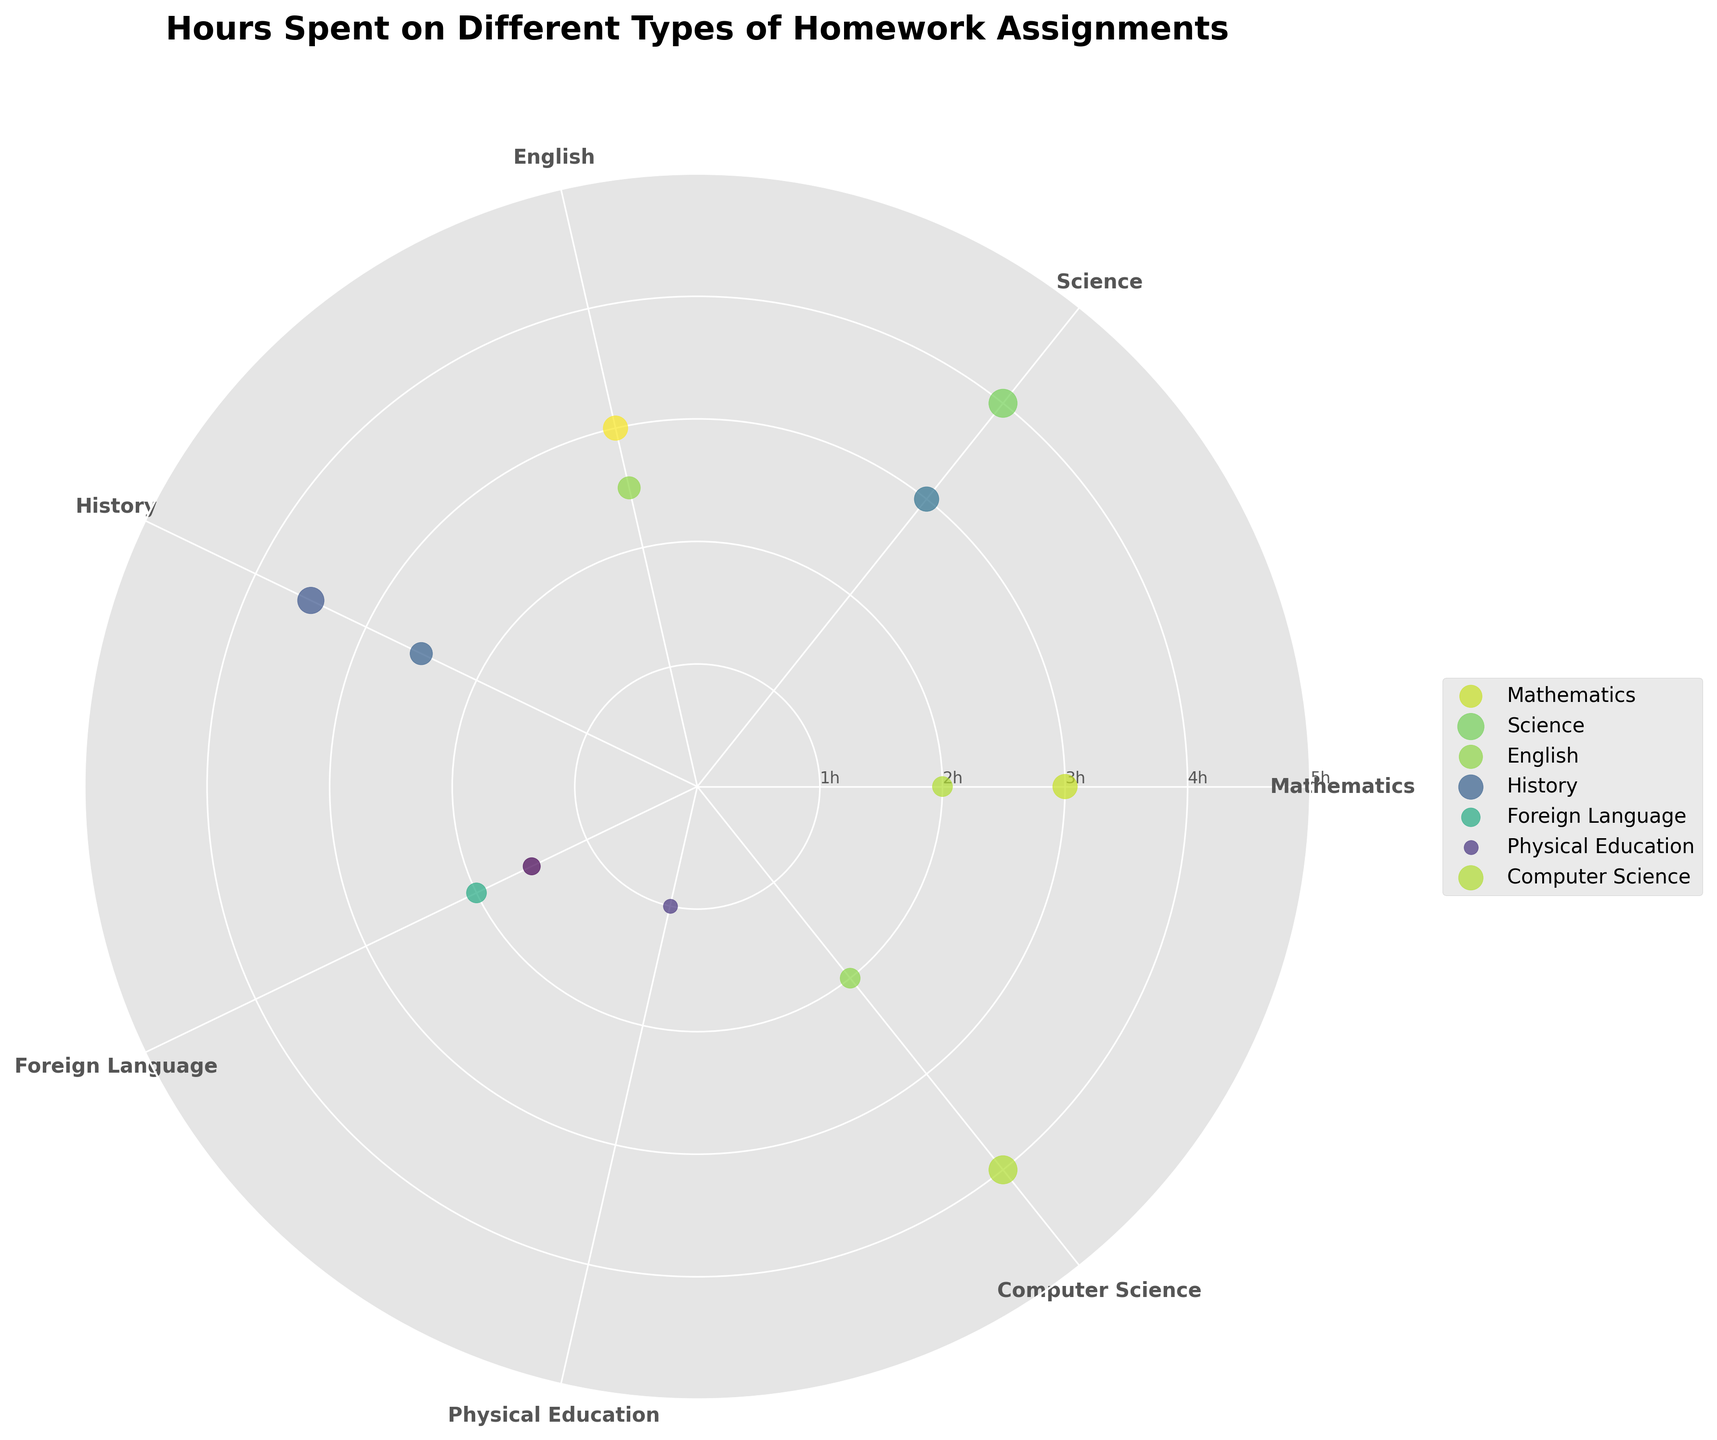What is the title of the chart? The title of the chart is located at the top and provides an overview of what the chart represents.
Answer: Hours Spent on Different Types of Homework Assignments How many subjects are represented in the chart? The number of distinct subjects can be determined by counting the labels around the circumference of the polar plot.
Answer: 8 Which subject has the most types of homework assignments? Each subject represented has a cluster of data points. Identify the subject with the highest number of distinct data points.
Answer: Mathematics What is the range of hours spent on Chemistry homework? The range can be found by identifying the data points for Chemistry and then determining the minimum and maximum values of these points. Chemistry has 3 hours.
Answer: 3 hours Compare the amount of time spent on Algebra and Geometry. Locate the data points for Algebra and Geometry within the Mathematics subject and compare their respective hours. Algebra has 3 hours, and Geometry has 2 hours.
Answer: More time is spent on Algebra Which subject requires the least amount of time for its assignments? Identify the subject with the data points closest to the center of the polar plot, indicating the lowest number of hours. Physical Education has 1 hour.
Answer: Physical Education What is the total number of hours spent on English assignments? Identify the data points for Literature and Essay Writing, then sum their respective hours. Literature has 2.5 hours, Essay Writing has 3 hours. The total is 2.5 + 3 = 5.5 hours.
Answer: 5.5 hours How does the time spent on Programming compare with Biology? Locate the data points for Programming and Biology and compare their respective hours. Programming has 4 hours, and Biology has 4 hours.
Answer: They are equal Which subject has the highest average hours per assignment? Calculate the average hours by summing the hours for each subject and dividing by the number of assignments for that subject. For example, Mathematics (3+2 = 5, avg = 5/2 = 2.5), Science (4+3 = 7, avg = 7/2 = 3.5), English (5.5/2 = 2.75), History (2.5+3.5 = 6, avg = 3), Foreign Language (2+1.5 = 3.5, avg = 1.75), Physical Education (1, avg = 1), Computer Science (4+2 = 6, avg = 3).
Answer: Science Identify the subject with assignments that vary the most in hours spent? Determine the variance in hours for each subject by identifying the range (difference between maximum and minimum values). For example, History ranges from 2.5 to 3.5, Chemistry is 3, Algebra and Geometry range from 3 to 2, etc.
Answer: History 